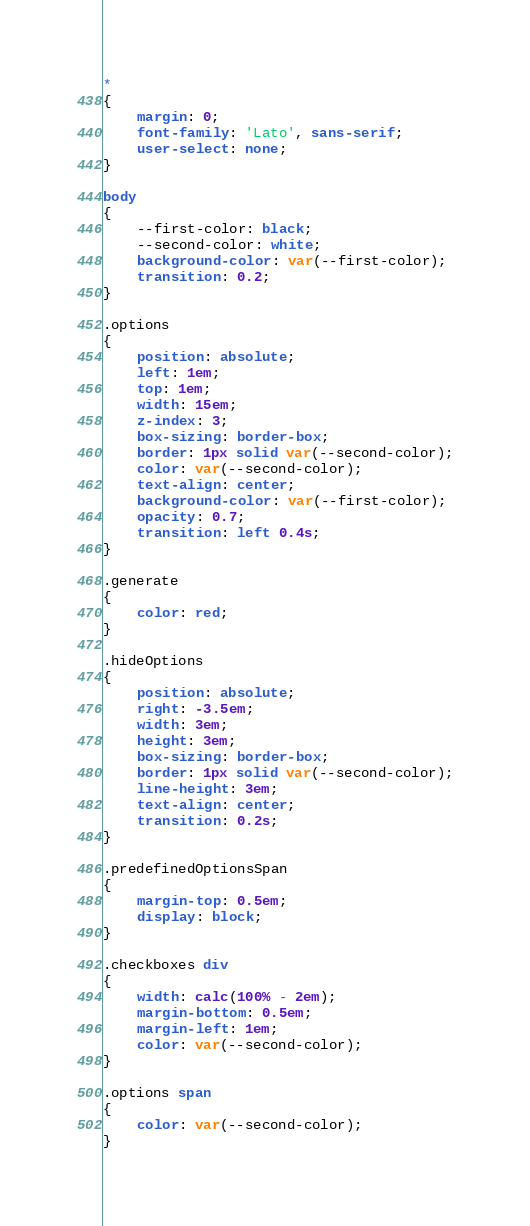Convert code to text. <code><loc_0><loc_0><loc_500><loc_500><_CSS_>*
{
	margin: 0;
	font-family: 'Lato', sans-serif;
	user-select: none;
}

body
{
	--first-color: black;
	--second-color: white;
	background-color: var(--first-color);
	transition: 0.2;
}

.options
{
	position: absolute;
	left: 1em;
	top: 1em;
	width: 15em;
	z-index: 3;
	box-sizing: border-box;
	border: 1px solid var(--second-color);
	color: var(--second-color);
	text-align: center;
	background-color: var(--first-color);
	opacity: 0.7;
	transition: left 0.4s;
}

.generate
{
	color: red;
}

.hideOptions
{
	position: absolute;
	right: -3.5em;
	width: 3em;
	height: 3em;
	box-sizing: border-box;
	border: 1px solid var(--second-color);
	line-height: 3em;
	text-align: center;
	transition: 0.2s;
}

.predefinedOptionsSpan
{
	margin-top: 0.5em;
	display: block;
}

.checkboxes div
{
	width: calc(100% - 2em);
	margin-bottom: 0.5em;
	margin-left: 1em;
	color: var(--second-color);
}

.options span
{
	color: var(--second-color);
}
</code> 